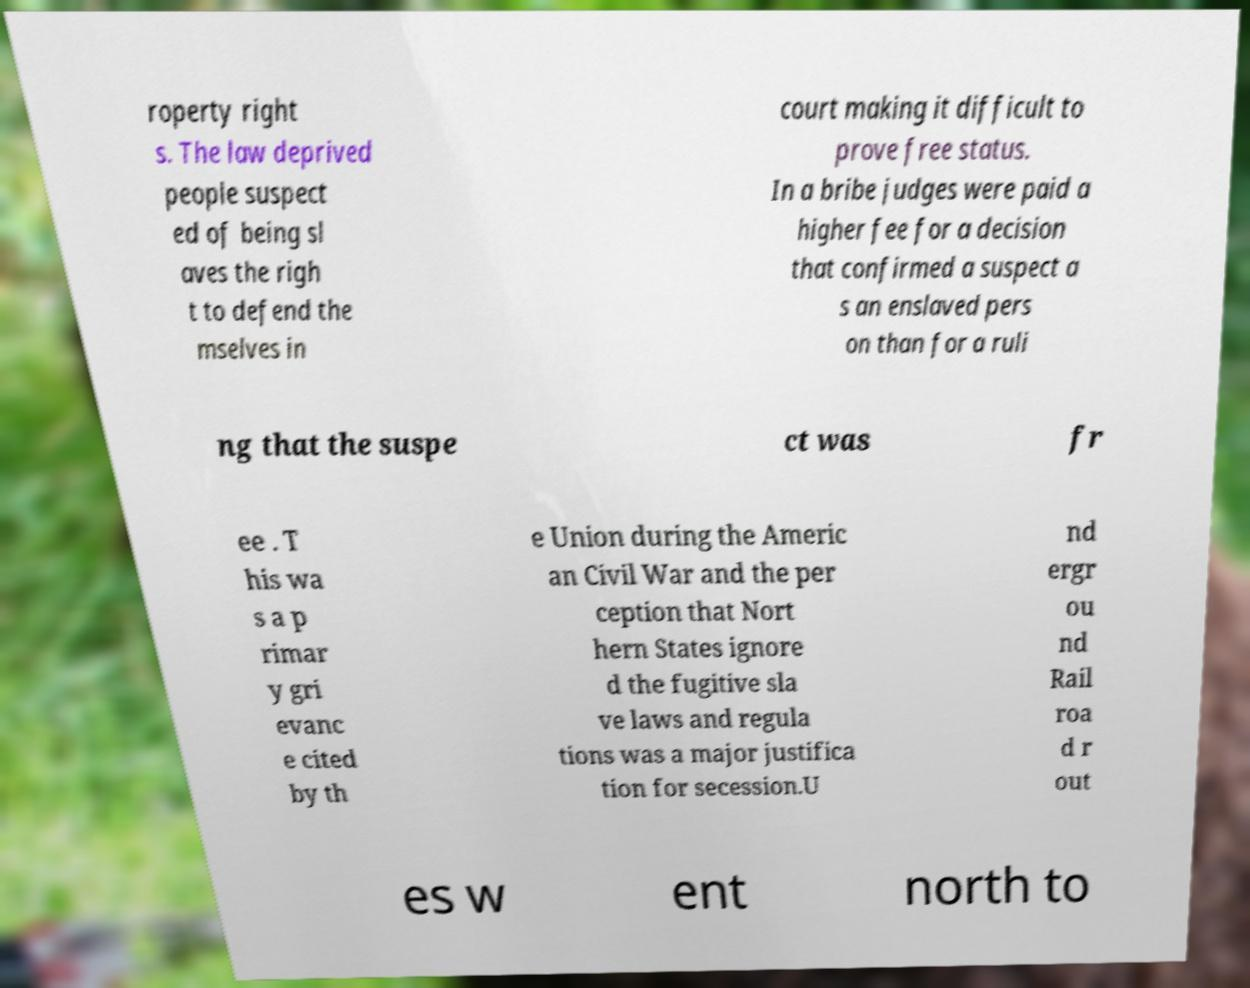There's text embedded in this image that I need extracted. Can you transcribe it verbatim? roperty right s. The law deprived people suspect ed of being sl aves the righ t to defend the mselves in court making it difficult to prove free status. In a bribe judges were paid a higher fee for a decision that confirmed a suspect a s an enslaved pers on than for a ruli ng that the suspe ct was fr ee . T his wa s a p rimar y gri evanc e cited by th e Union during the Americ an Civil War and the per ception that Nort hern States ignore d the fugitive sla ve laws and regula tions was a major justifica tion for secession.U nd ergr ou nd Rail roa d r out es w ent north to 